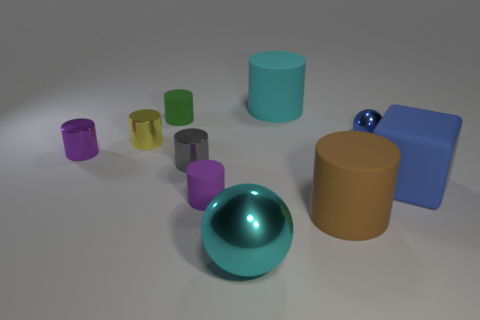Is the number of large brown things on the left side of the green cylinder the same as the number of big cyan shiny things?
Give a very brief answer. No. There is a small purple object that is made of the same material as the brown cylinder; what shape is it?
Keep it short and to the point. Cylinder. Are there any small metallic spheres of the same color as the large sphere?
Offer a terse response. No. How many metallic objects are either big gray spheres or yellow cylinders?
Give a very brief answer. 1. How many small gray metal things are to the left of the tiny metallic object that is on the right side of the large cyan matte thing?
Provide a succinct answer. 1. What number of tiny green objects have the same material as the green cylinder?
Ensure brevity in your answer.  0. What number of small things are either rubber objects or brown things?
Make the answer very short. 2. What shape is the shiny object that is to the right of the purple matte object and in front of the blue metallic ball?
Provide a succinct answer. Sphere. Is the cyan cylinder made of the same material as the big block?
Provide a short and direct response. Yes. There is a sphere that is the same size as the gray thing; what is its color?
Offer a terse response. Blue. 